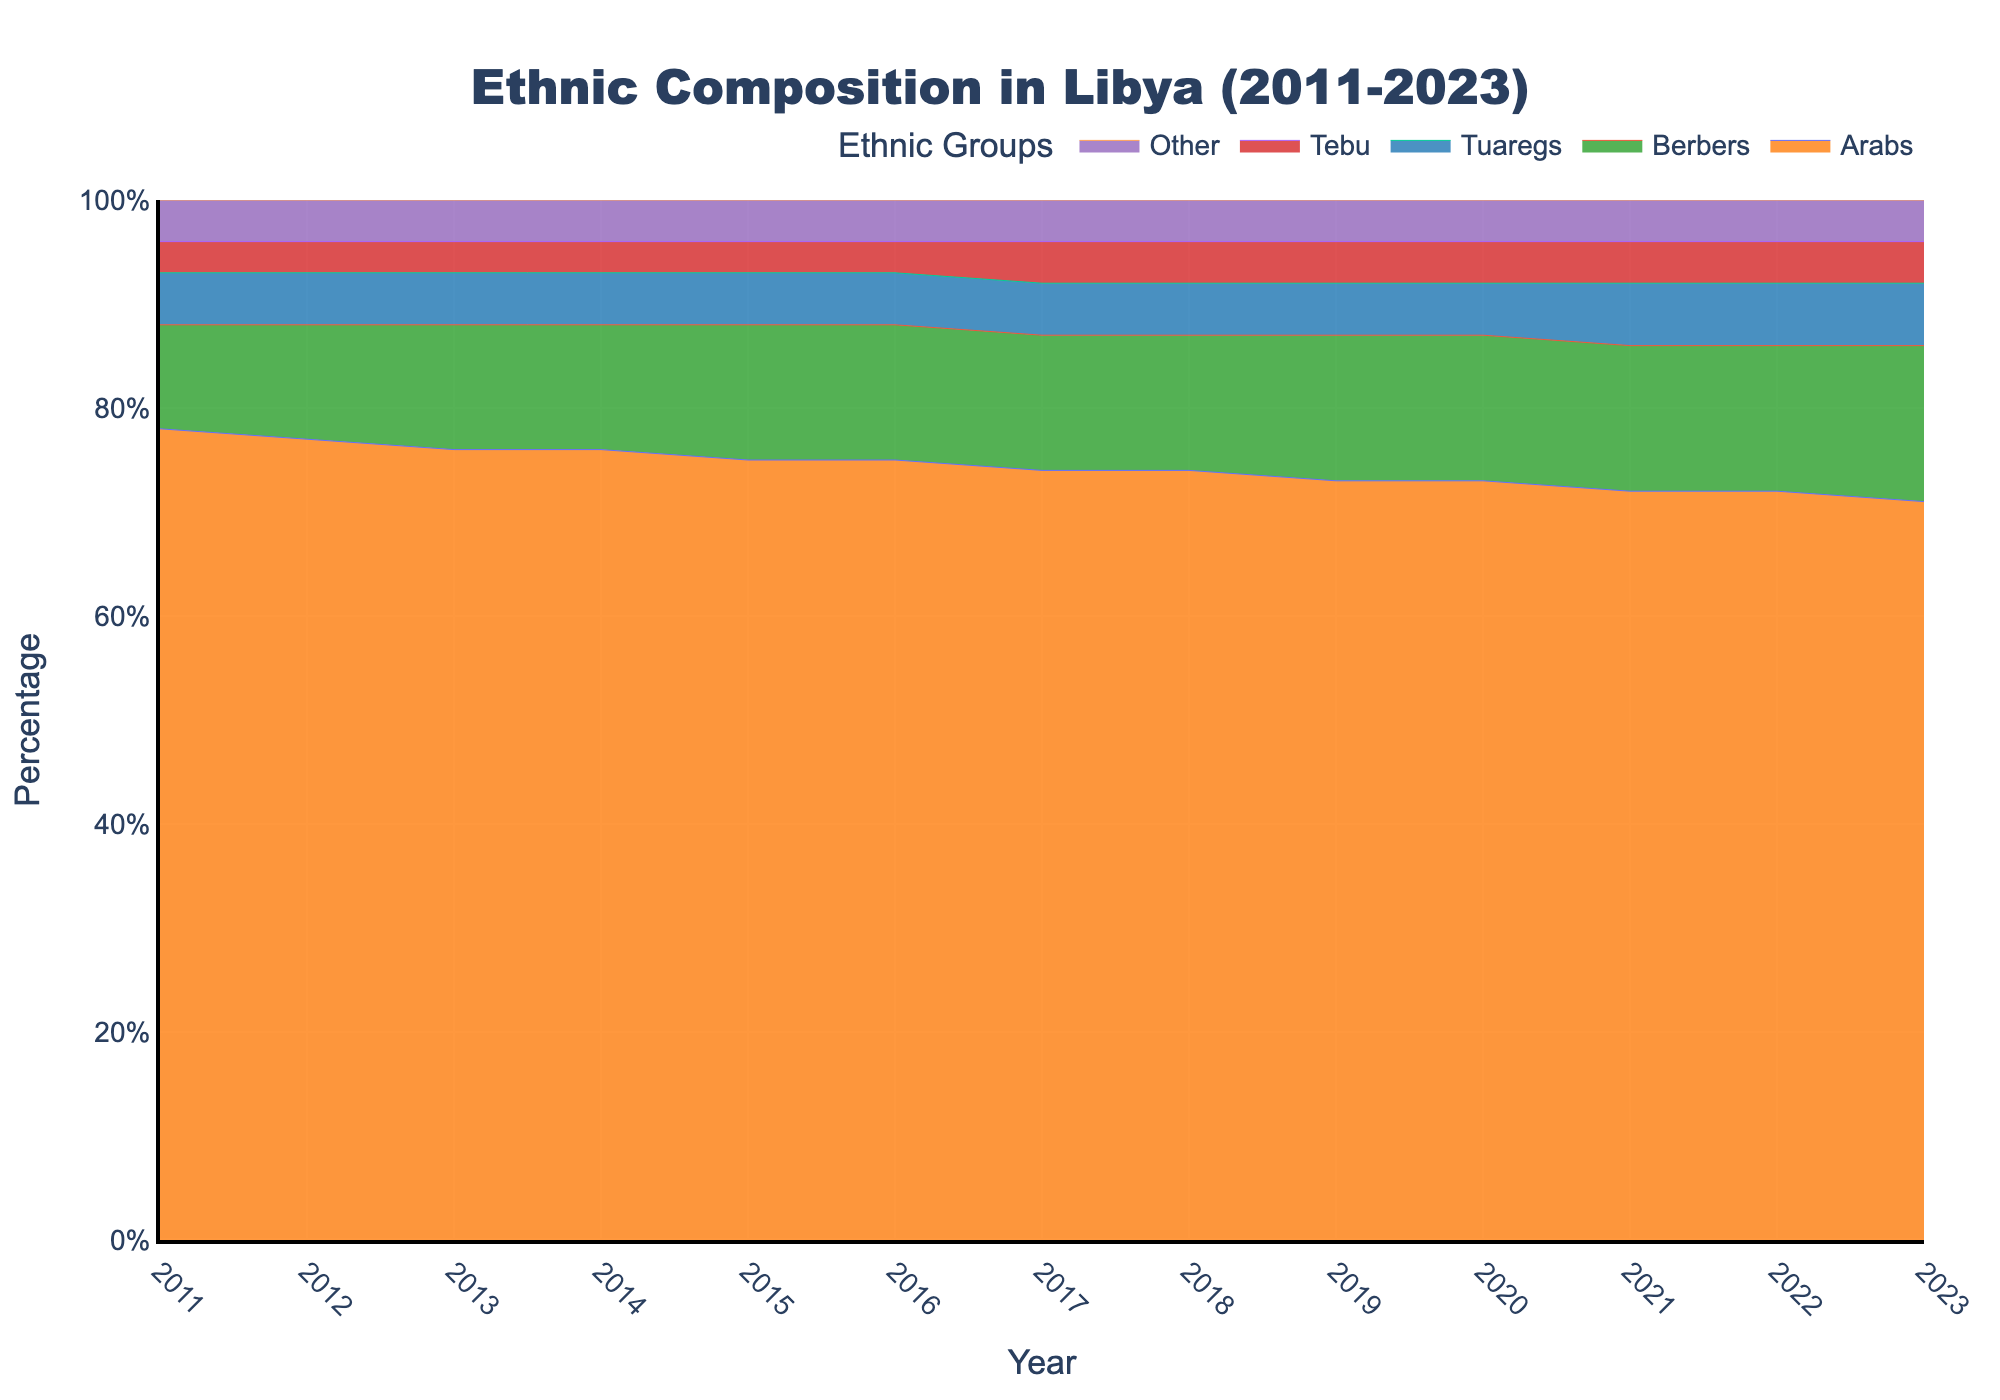What is the title of the plot? The title is typically found at the top of the figure. In this case, the title provided in the code is "Ethnic Composition in Libya (2011-2023)"
Answer: Ethnic Composition in Libya (2011-2023) Which year shows the highest percentage of Arabs? By examining the 100% Stacked Area Chart, we can look at the segment representing Arabs across different years and identify the peak percentage. In 2011, Arabs make up 78% of the population, which is the highest percentage shown in the data.
Answer: 2011 How does the percentage of Berbers change from 2011 to 2023? To analyze this, identify the percentage of Berbers in 2011 and in 2023 from the chart. In 2011, Berbers were 10%, and by 2023, they increased to 15%. The percentage rose by 5% over this period.
Answer: Increased from 10% to 15% Which ethnic group's percentage increased the most from 2011 to 2023? To find this, compare the percentage changes for each ethnic group from 2011 to 2023. Arabs decreased by 7% (78% to 71%), Berbers increased by 5% (10% to 15%), Tuaregs increased by 1% (5% to 6%), Tebu increased by 1% (3% to 4%), and Other remained the same (4%). Hence, Berbers had the largest increase.
Answer: Berbers What is the average percentage of Tuaregs across all years presented? Sum the percentages of Tuaregs for each year and divide by the number of years. (5% + 5% + 5% + 5% + 5% + 5% + 5% + 5% + 5% + 5% + 6% + 6% + 6%) / 13 = 65% / 13 = 5%. So, the average percentage is 5%.
Answer: 5% In which year did the Tebu group's percentage first increase? By examining the chart, we see that the Tebu percentage increased from 3% to 4% in 2017. This is the first recorded increase for this group.
Answer: 2017 What is the combined percentage of other ethnic groups (excluding Arabs) in 2020? Add the percentages of Berbers, Tuaregs, Tebu, and Other for 2020. Berbers (14%) + Tuaregs (5%) + Tebu (4%) + Other (4%) = 27%.
Answer: 27% Which group has maintained a constant percentage over multiple consecutive years? By scanning the chart, we notice the "Other" group stayed constant at 4% from 2011 to 2023.
Answer: Other How did the percentage of Arabs change from 2015 to 2020? Identify the percentage of Arabs in 2015 and 2020 from the chart. In 2015, Arabs were 75%, and in 2020, they were 73%. The percentage decreased by 2%.
Answer: Decreased by 2% Which two ethnic groups reached an equal percentage in any year? By looking closely at the stacked areas, we see that Tuaregs and Tebu each had 5% in various years (2011-2019) and both had 6% in years 2021 to 2023.
Answer: Tuaregs and Tebu In which year did the percentage of Arabs first go below 75%? Observing the chart, the percentage of Arabs first drops below 75% in 2017, where it is recorded at 74%.
Answer: 2017 